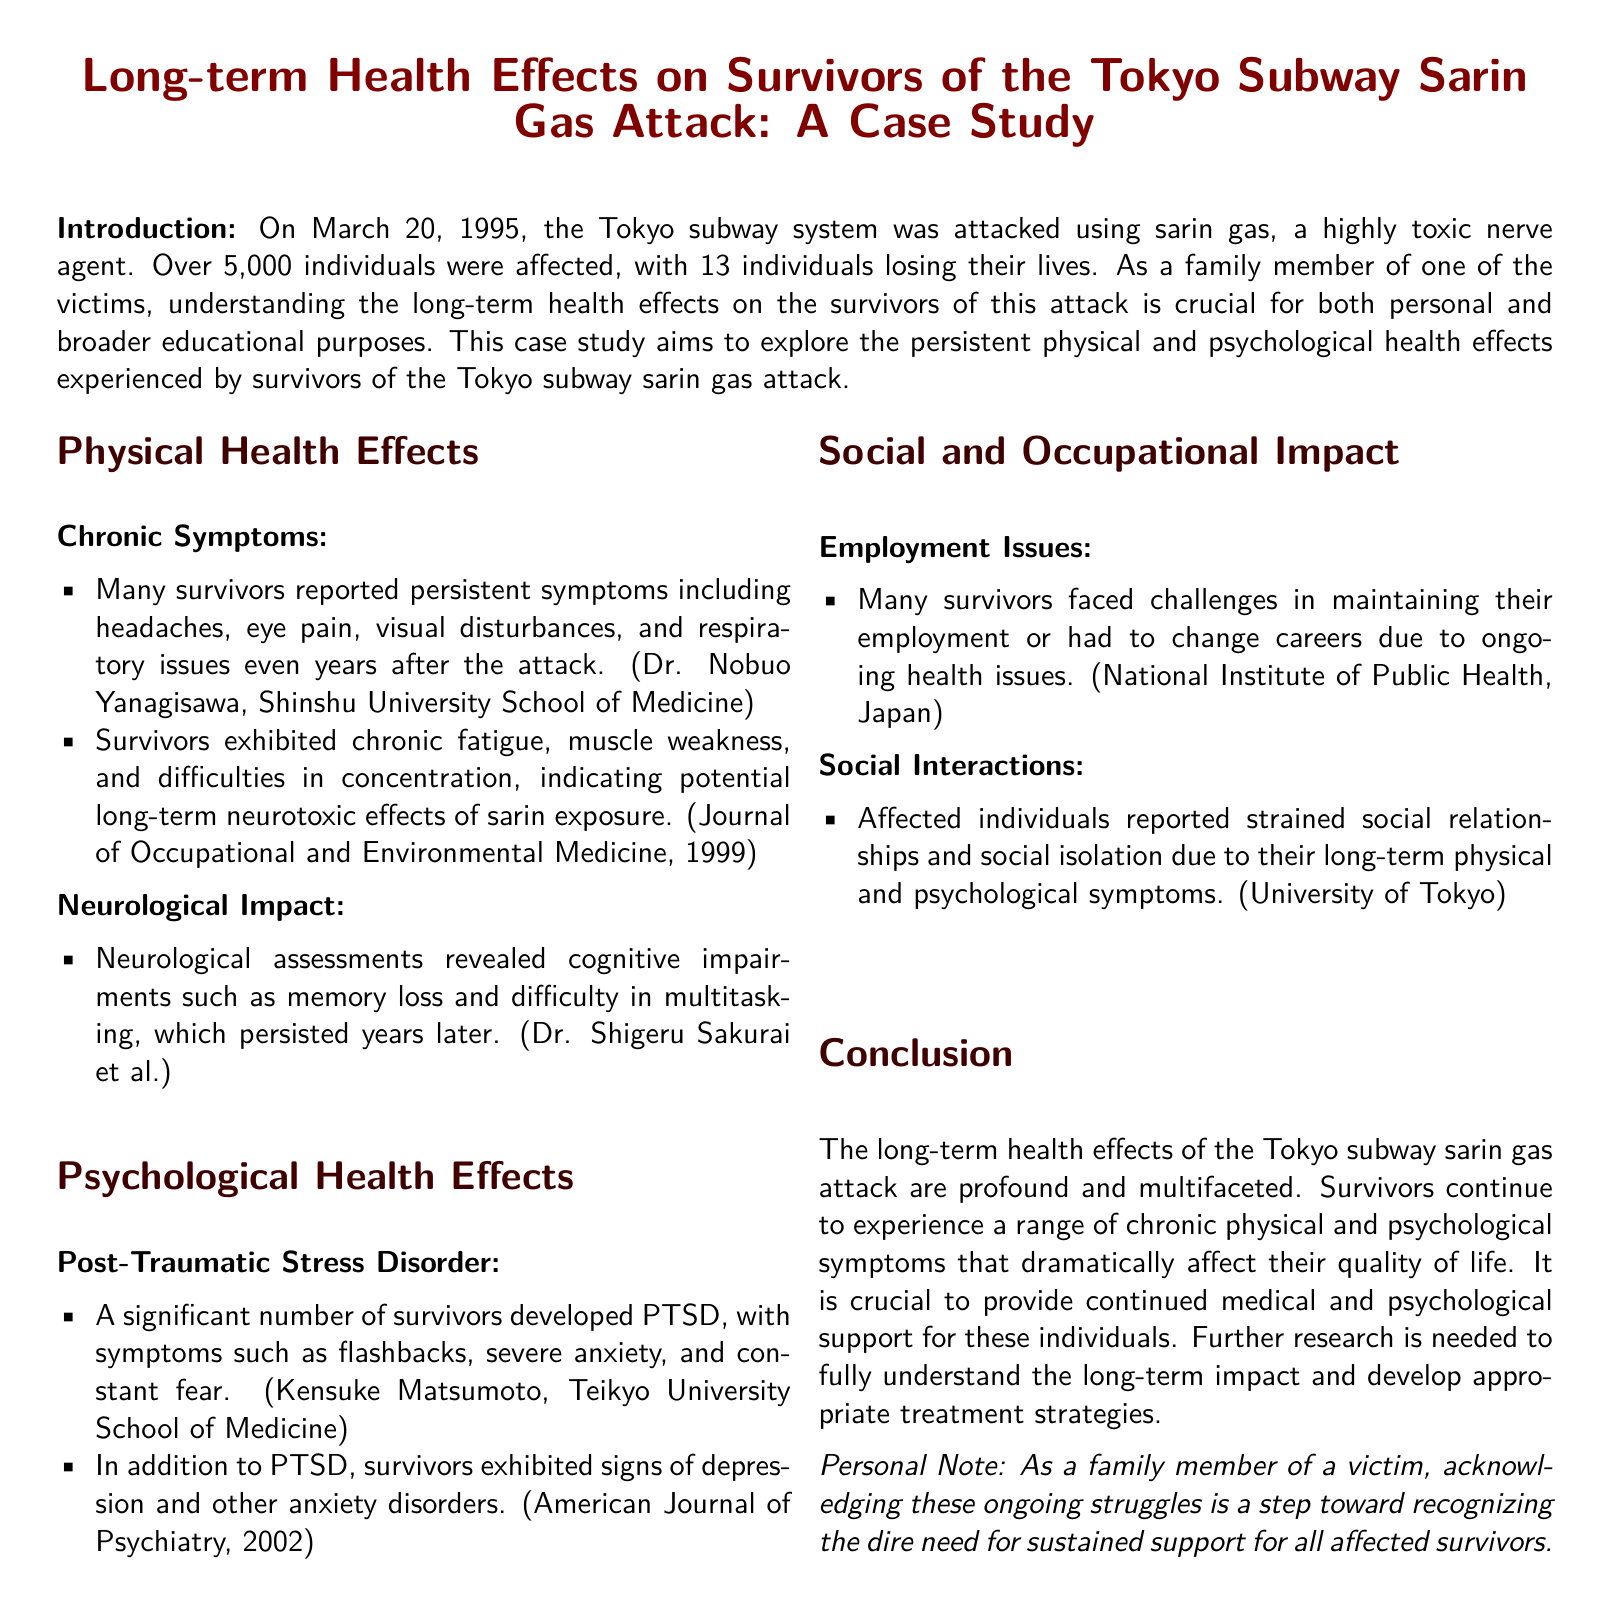what date did the Tokyo subway sarin gas attack occur? The document specifies that the attack occurred on March 20, 1995.
Answer: March 20, 1995 how many individuals lost their lives in the attack? The document states that 13 individuals lost their lives due to the attack.
Answer: 13 which medical professional is mentioned regarding chronic symptoms? The document mentions Dr. Nobuo Yanagisawa in connection with chronic symptoms reported by survivors.
Answer: Dr. Nobuo Yanagisawa what psychological condition was significantly noted among the survivors? Post-Traumatic Stress Disorder (PTSD) is the condition highlighted in the document as commonly developed among survivors.
Answer: PTSD what effects did survivors experience related to their employment? The document describes that many survivors faced challenges in maintaining their employment due to ongoing health issues.
Answer: Challenges in employment which institution conducted research on the social impact on survivors? The document cites the University of Tokyo for research related to social interactions of affected individuals.
Answer: University of Tokyo what type of support is deemed crucial for survivors according to the conclusion? The conclusion indicates that continued medical and psychological support is vital for survivors.
Answer: Continued support what is a common symptom reported years after the attack? Survivors reported persistent headaches as a common symptom years after the attack.
Answer: Headaches 